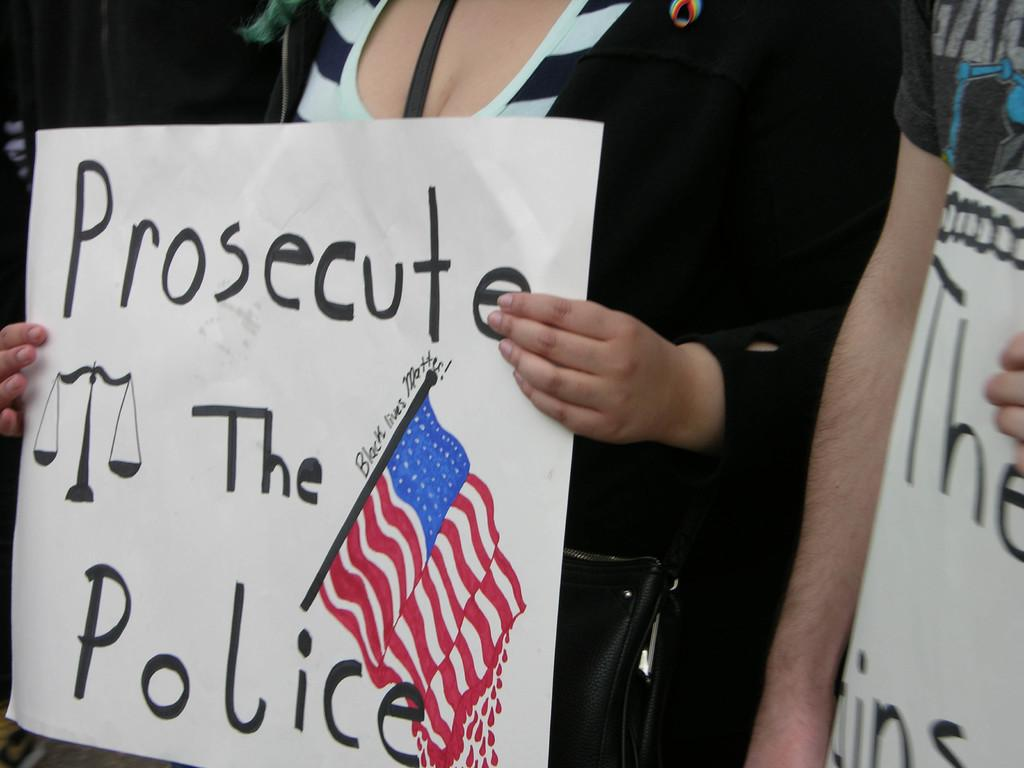Provide a one-sentence caption for the provided image. A woman holds a sign that says, "Prosecute the Police". 